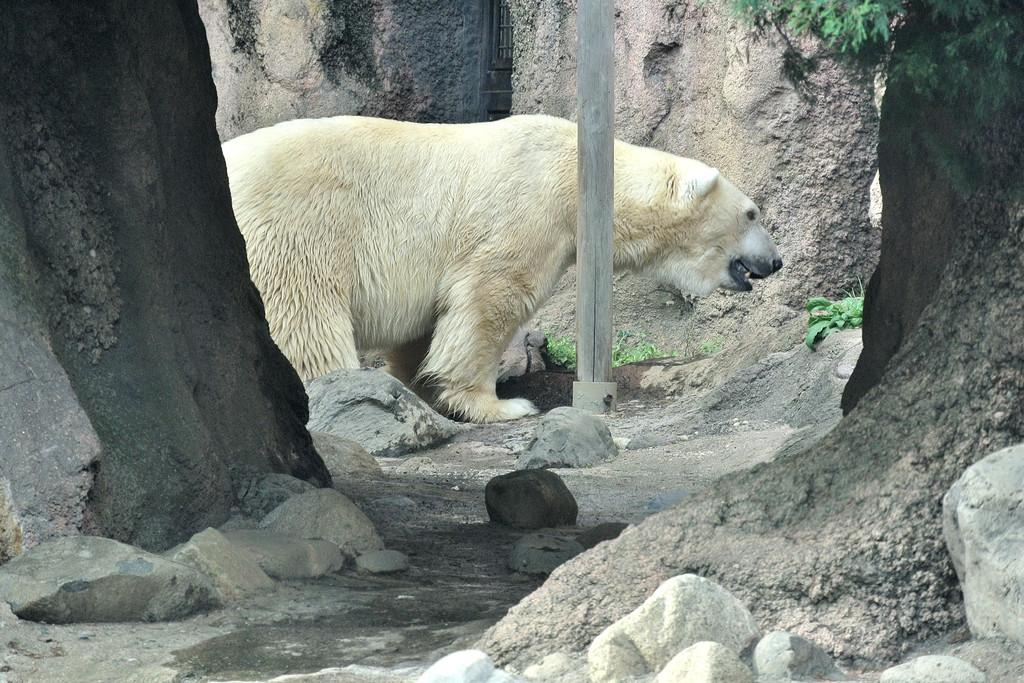What animal is in the center of the image? There is a polar bear in the center of the image. What type of natural elements can be seen in the image? Stones, plants, and the bark of trees are visible in the image. What man-made object is present in the image? There is a wooden pole in the image. What type of music is the polar bear playing in the image? There is no music or indication of music in the image; it features a polar bear and other natural elements. 